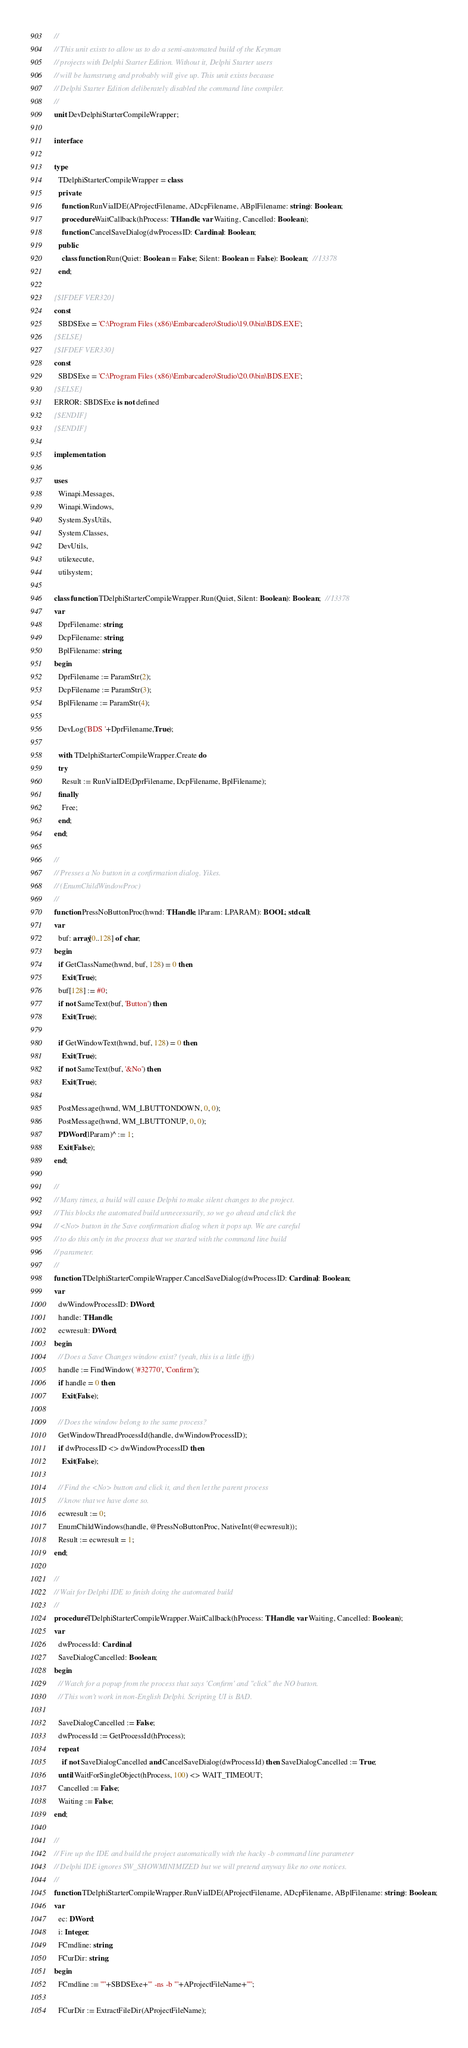Convert code to text. <code><loc_0><loc_0><loc_500><loc_500><_Pascal_>//
// This unit exists to allow us to do a semi-automated build of the Keyman
// projects with Delphi Starter Edition. Without it, Delphi Starter users
// will be hamstrung and probably will give up. This unit exists because
// Delphi Starter Edition deliberately disabled the command line compiler.
//
unit DevDelphiStarterCompileWrapper;

interface

type
  TDelphiStarterCompileWrapper = class
  private
    function RunViaIDE(AProjectFilename, ADcpFilename, ABplFilename: string): Boolean;
    procedure WaitCallback(hProcess: THandle; var Waiting, Cancelled: Boolean);
    function CancelSaveDialog(dwProcessID: Cardinal): Boolean;
  public
    class function Run(Quiet: Boolean = False; Silent: Boolean = False): Boolean;  // I3378
  end;

{$IFDEF VER320}
const
  SBDSExe = 'C:\Program Files (x86)\Embarcadero\Studio\19.0\bin\BDS.EXE';
{$ELSE}
{$IFDEF VER330}
const
  SBDSExe = 'C:\Program Files (x86)\Embarcadero\Studio\20.0\bin\BDS.EXE';
{$ELSE}
ERROR: SBDSExe is not defined
{$ENDIF}
{$ENDIF}

implementation

uses
  Winapi.Messages,
  Winapi.Windows,
  System.SysUtils,
  System.Classes,
  DevUtils,
  utilexecute,
  utilsystem;

class function TDelphiStarterCompileWrapper.Run(Quiet, Silent: Boolean): Boolean;  // I3378
var
  DprFilename: string;
  DcpFilename: string;
  BplFilename: string;
begin
  DprFilename := ParamStr(2);
  DcpFilename := ParamStr(3);
  BplFilename := ParamStr(4);

  DevLog('BDS '+DprFilename,True);

  with TDelphiStarterCompileWrapper.Create do
  try
    Result := RunViaIDE(DprFilename, DcpFilename, BplFilename);
  finally
    Free;
  end;
end;

//
// Presses a No button in a confirmation dialog. Yikes.
// (EnumChildWindowProc)
//
function PressNoButtonProc(hwnd: THandle; lParam: LPARAM): BOOL; stdcall;
var
  buf: array[0..128] of char;
begin
  if GetClassName(hwnd, buf, 128) = 0 then
    Exit(True);
  buf[128] := #0;
  if not SameText(buf, 'Button') then
    Exit(True);

  if GetWindowText(hwnd, buf, 128) = 0 then
    Exit(True);
  if not SameText(buf, '&No') then
    Exit(True);

  PostMessage(hwnd, WM_LBUTTONDOWN, 0, 0);
  PostMessage(hwnd, WM_LBUTTONUP, 0, 0);
  PDWord(lParam)^ := 1;
  Exit(False);
end;

//
// Many times, a build will cause Delphi to make silent changes to the project.
// This blocks the automated build unnecessarily, so we go ahead and click the
// <No> button in the Save confirmation dialog when it pops up. We are careful
// to do this only in the process that we started with the command line build
// parameter.
//
function TDelphiStarterCompileWrapper.CancelSaveDialog(dwProcessID: Cardinal): Boolean;
var
  dwWindowProcessID: DWord;
  handle: THandle;
  ecwresult: DWord;
begin
  // Does a Save Changes window exist? (yeah, this is a little iffy)
  handle := FindWindow( '#32770', 'Confirm');
  if handle = 0 then
    Exit(False);

  // Does the window belong to the same process?
  GetWindowThreadProcessId(handle, dwWindowProcessID);
  if dwProcessID <> dwWindowProcessID then
    Exit(False);

  // Find the <No> button and click it, and then let the parent process
  // know that we have done so.
  ecwresult := 0;
  EnumChildWindows(handle, @PressNoButtonProc, NativeInt(@ecwresult));
  Result := ecwresult = 1;
end;

//
// Wait for Delphi IDE to finish doing the automated build
//
procedure TDelphiStarterCompileWrapper.WaitCallback(hProcess: THandle; var Waiting, Cancelled: Boolean);
var
  dwProcessId: Cardinal;
  SaveDialogCancelled: Boolean;
begin
  // Watch for a popup from the process that says 'Confirm' and "click" the NO button.
  // This won't work in non-English Delphi. Scripting UI is BAD.

  SaveDialogCancelled := False;
  dwProcessId := GetProcessId(hProcess);
  repeat
    if not SaveDialogCancelled and CancelSaveDialog(dwProcessId) then SaveDialogCancelled := True;
  until WaitForSingleObject(hProcess, 100) <> WAIT_TIMEOUT;
  Cancelled := False;
  Waiting := False;
end;

//
// Fire up the IDE and build the project automatically with the hacky -b command line parameter
// Delphi IDE ignores SW_SHOWMINIMIZED but we will pretend anyway like no one notices.
//
function TDelphiStarterCompileWrapper.RunViaIDE(AProjectFilename, ADcpFilename, ABplFilename: string): Boolean;
var
  ec: DWord;
  i: Integer;
  FCmdline: string;
  FCurDir: string;
begin
  FCmdline := '"'+SBDSExe+'" -ns -b "'+AProjectFileName+'"';

  FCurDir := ExtractFileDir(AProjectFileName);</code> 